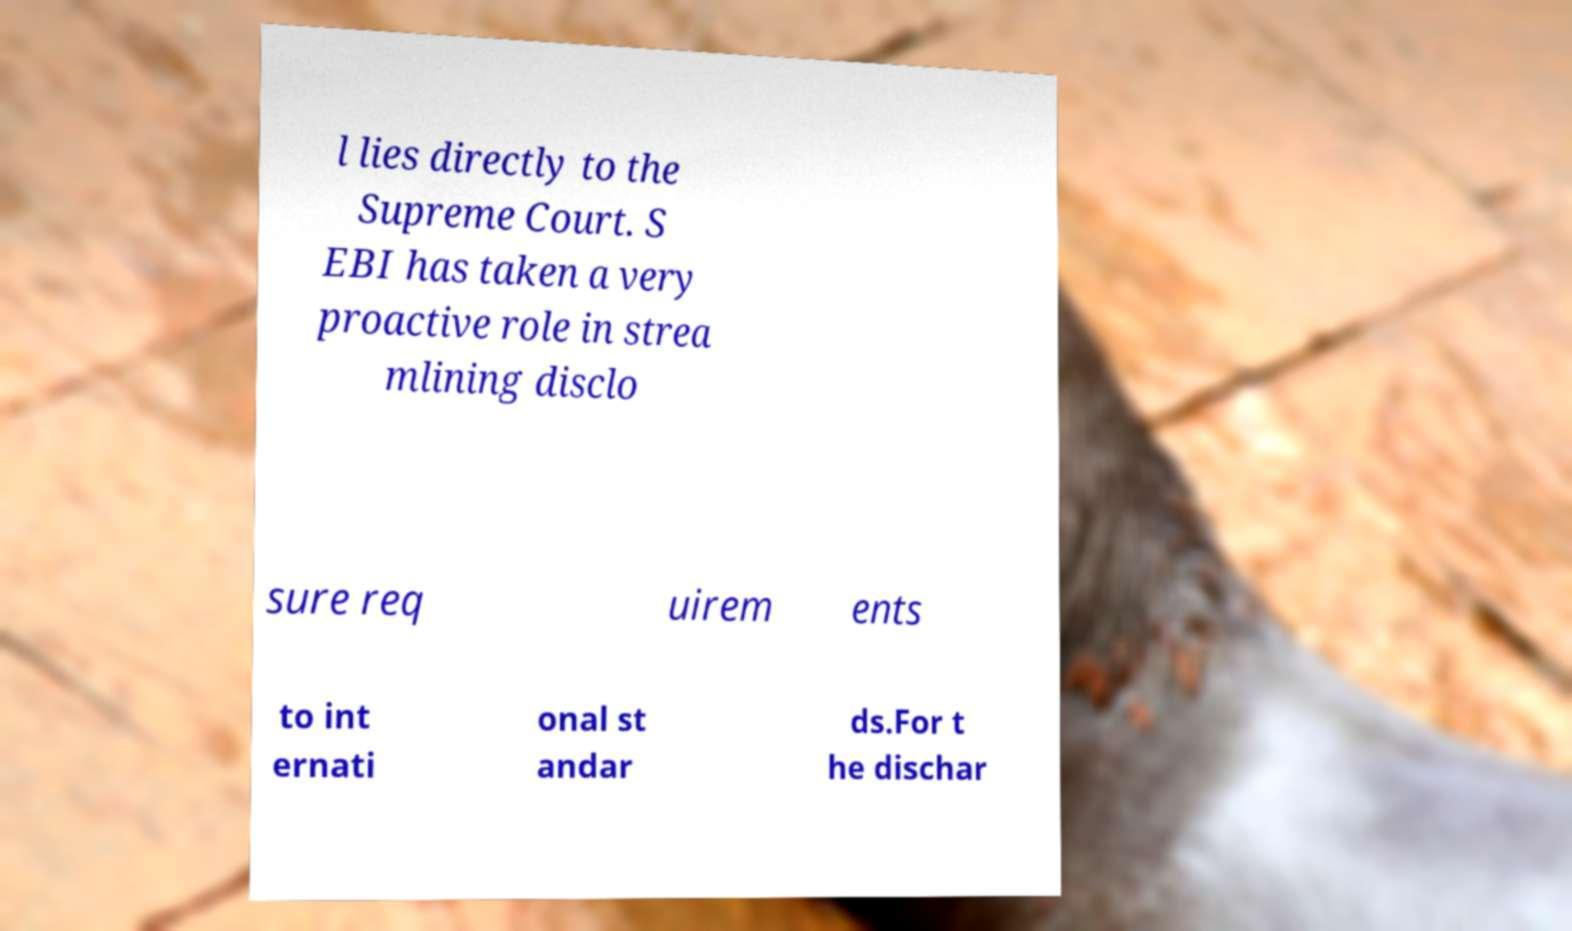There's text embedded in this image that I need extracted. Can you transcribe it verbatim? l lies directly to the Supreme Court. S EBI has taken a very proactive role in strea mlining disclo sure req uirem ents to int ernati onal st andar ds.For t he dischar 